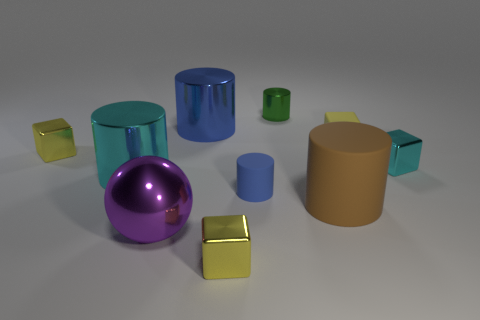Are there any objects that look similar in shape but different in size? Yes, there are two pairs of similarly shaped objects that vary in size. The cylinders, one large in brown and a smaller one in blue, and two cubes, a large yellow and a smaller one in cyan.  Can you tell if the light source in the scene is coming from a specific direction? The shadows on the ground and the highlights on the objects suggest that the light source is coming from the upper left side of the scene. 